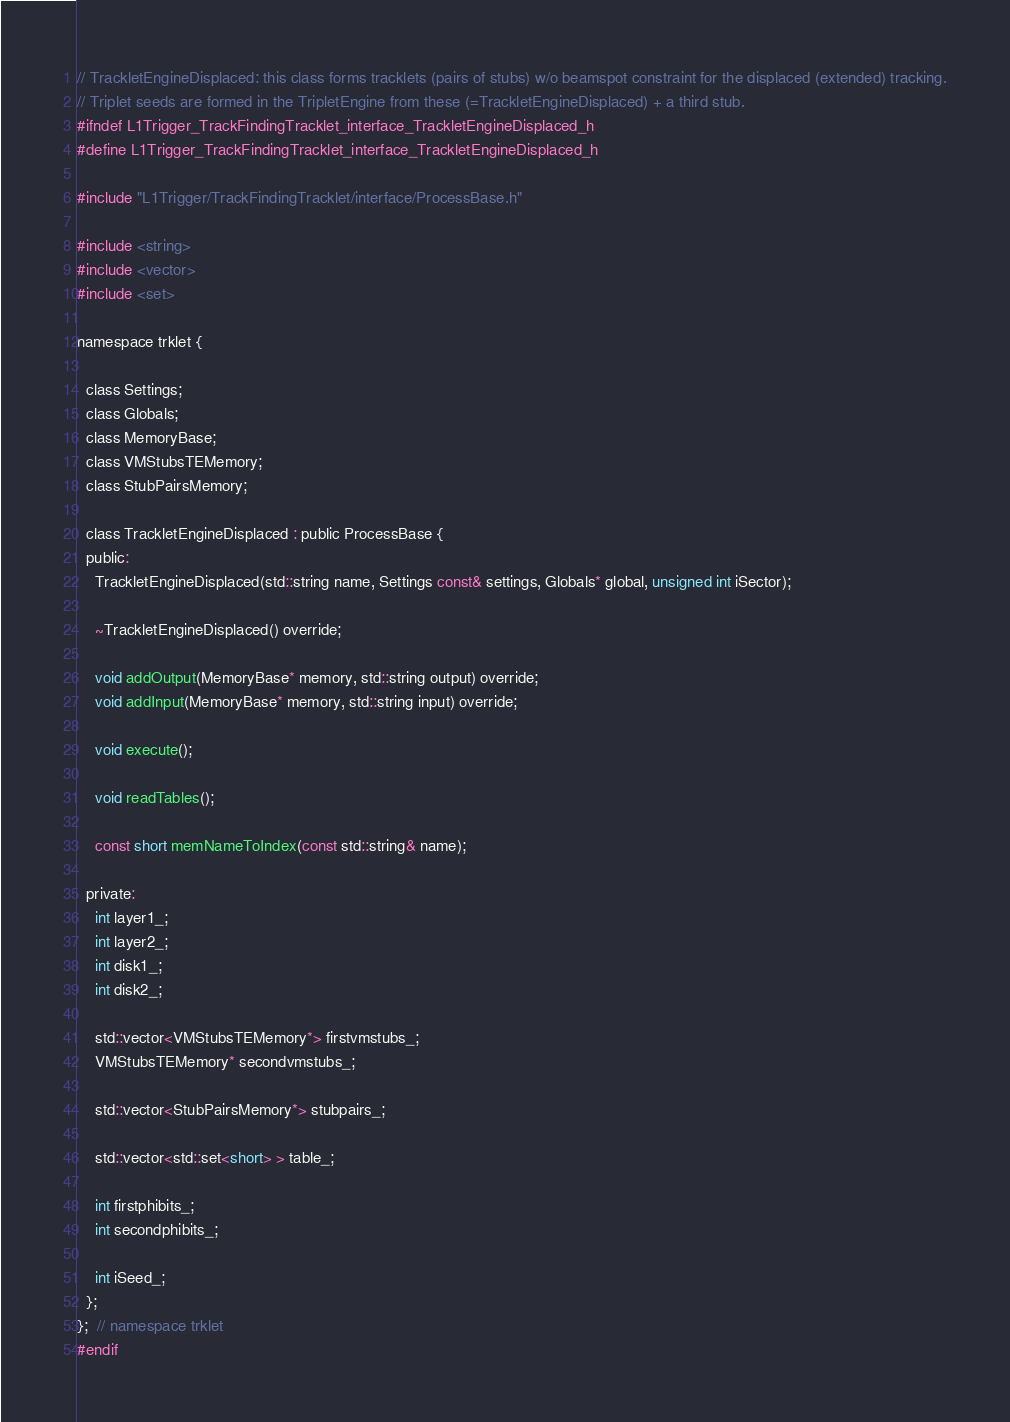Convert code to text. <code><loc_0><loc_0><loc_500><loc_500><_C_>// TrackletEngineDisplaced: this class forms tracklets (pairs of stubs) w/o beamspot constraint for the displaced (extended) tracking.
// Triplet seeds are formed in the TripletEngine from these (=TrackletEngineDisplaced) + a third stub.
#ifndef L1Trigger_TrackFindingTracklet_interface_TrackletEngineDisplaced_h
#define L1Trigger_TrackFindingTracklet_interface_TrackletEngineDisplaced_h

#include "L1Trigger/TrackFindingTracklet/interface/ProcessBase.h"

#include <string>
#include <vector>
#include <set>

namespace trklet {

  class Settings;
  class Globals;
  class MemoryBase;
  class VMStubsTEMemory;
  class StubPairsMemory;

  class TrackletEngineDisplaced : public ProcessBase {
  public:
    TrackletEngineDisplaced(std::string name, Settings const& settings, Globals* global, unsigned int iSector);

    ~TrackletEngineDisplaced() override;

    void addOutput(MemoryBase* memory, std::string output) override;
    void addInput(MemoryBase* memory, std::string input) override;

    void execute();

    void readTables();

    const short memNameToIndex(const std::string& name);

  private:
    int layer1_;
    int layer2_;
    int disk1_;
    int disk2_;

    std::vector<VMStubsTEMemory*> firstvmstubs_;
    VMStubsTEMemory* secondvmstubs_;

    std::vector<StubPairsMemory*> stubpairs_;

    std::vector<std::set<short> > table_;

    int firstphibits_;
    int secondphibits_;

    int iSeed_;
  };
};  // namespace trklet
#endif
</code> 